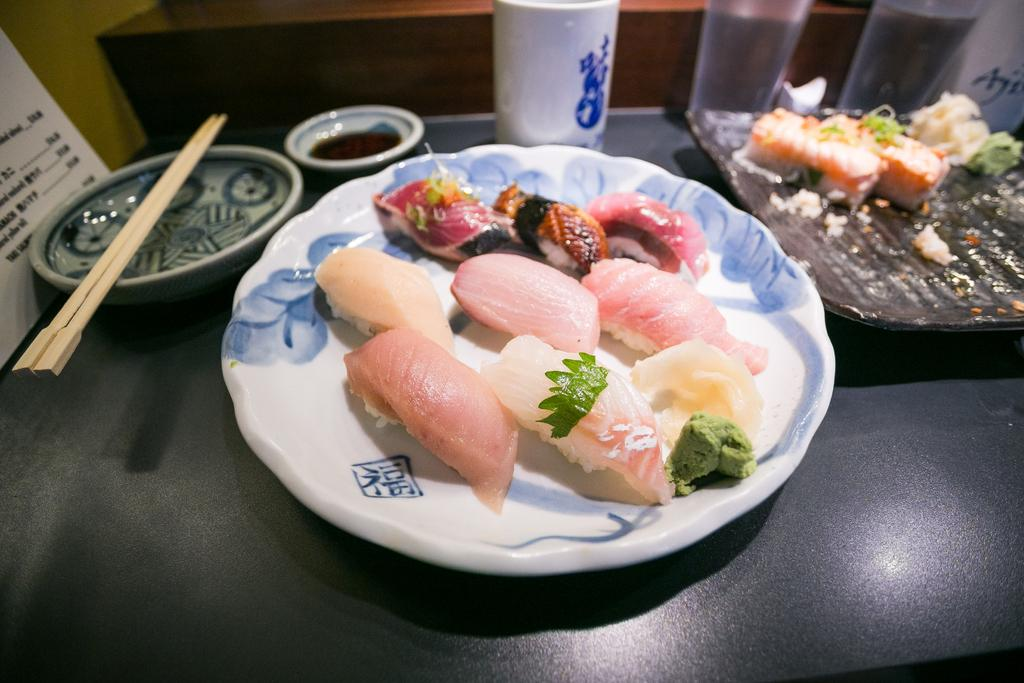What is on the plate that is visible in the image? There is a plate with food in the image. What utensils are visible in the image? Chopsticks are visible in the image. What might be used for ordering food in the image? There is a menu card in the image for ordering food. What type of containers are present in the image for holding liquids? Glasses and a cup are present in the image for holding liquids. What is on the table in the image besides the plate and utensils? There is a bowl on the table in the image. What is the slope of the table in the image? There is no slope mentioned or visible in the image; the table appears to be flat. How does the help arrive in the image? There is no indication of help arriving in the image; it only shows a plate with food, chopsticks, a menu card, glasses, a cup, and a bowl on the table. 